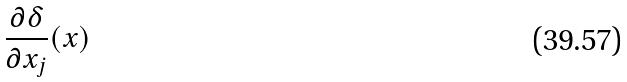Convert formula to latex. <formula><loc_0><loc_0><loc_500><loc_500>\frac { \partial \delta } { \partial x _ { j } } ( x )</formula> 